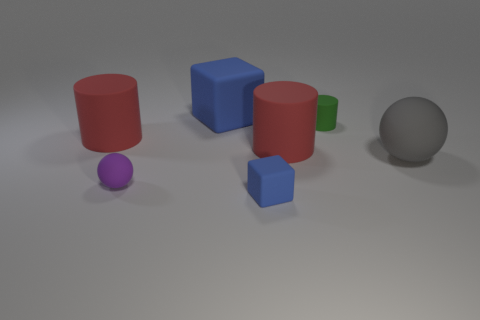Is there any other thing that has the same size as the purple sphere?
Make the answer very short. Yes. There is another cube that is the same color as the small rubber cube; what is its size?
Provide a succinct answer. Large. What is the size of the blue rubber block behind the rubber cube that is in front of the green matte cylinder that is on the left side of the big matte sphere?
Your answer should be very brief. Large. How many balls are the same material as the tiny green cylinder?
Make the answer very short. 2. How many blue rubber objects are the same size as the green rubber cylinder?
Give a very brief answer. 1. There is a blue cube that is behind the large gray rubber sphere that is on the right side of the blue matte cube that is behind the tiny ball; what is its material?
Your answer should be compact. Rubber. How many things are matte blocks or small cylinders?
Your answer should be compact. 3. Are there any other things that have the same material as the small sphere?
Give a very brief answer. Yes. What is the shape of the small purple thing?
Your answer should be very brief. Sphere. What is the shape of the big red matte thing that is in front of the red cylinder on the left side of the purple rubber object?
Offer a very short reply. Cylinder. 